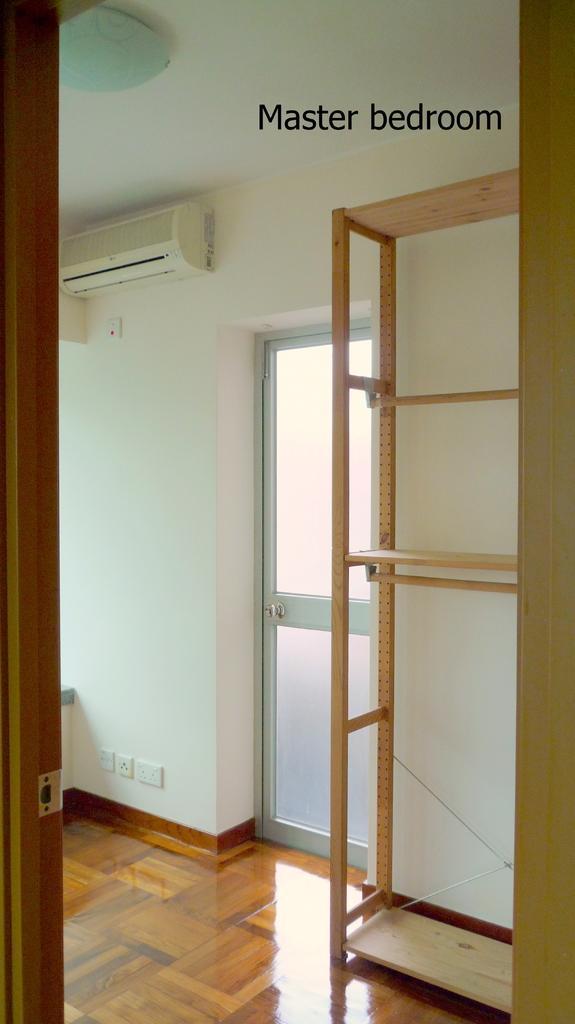Describe this image in one or two sentences. This is a room. In this room there is a wooden shelf. Near to that there is a door. Also there is a wall. On that there is an AC. And something written on the image. Also there is a wooden door. 